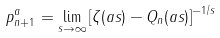Convert formula to latex. <formula><loc_0><loc_0><loc_500><loc_500>p _ { n + 1 } ^ { a } = \lim _ { s \to \infty } \left [ \zeta ( a s ) - Q _ { n } ( a s ) \right ] ^ { - 1 / s }</formula> 